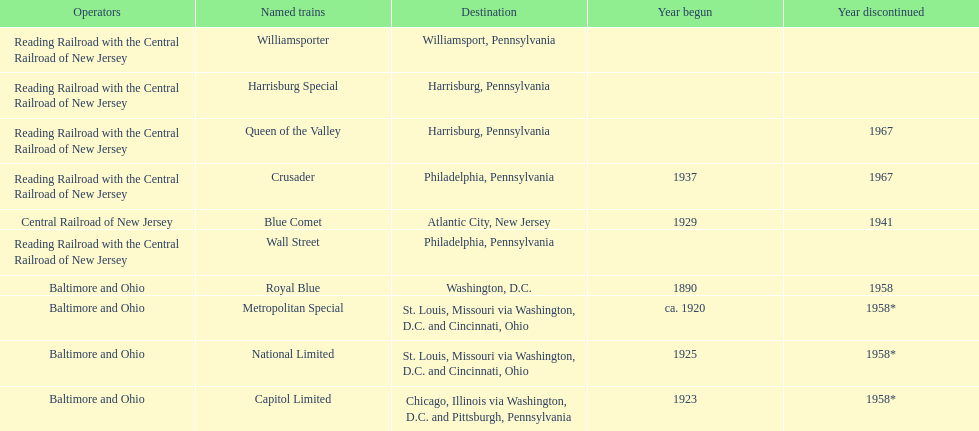What destination is at the top of the list? Chicago, Illinois via Washington, D.C. and Pittsburgh, Pennsylvania. 